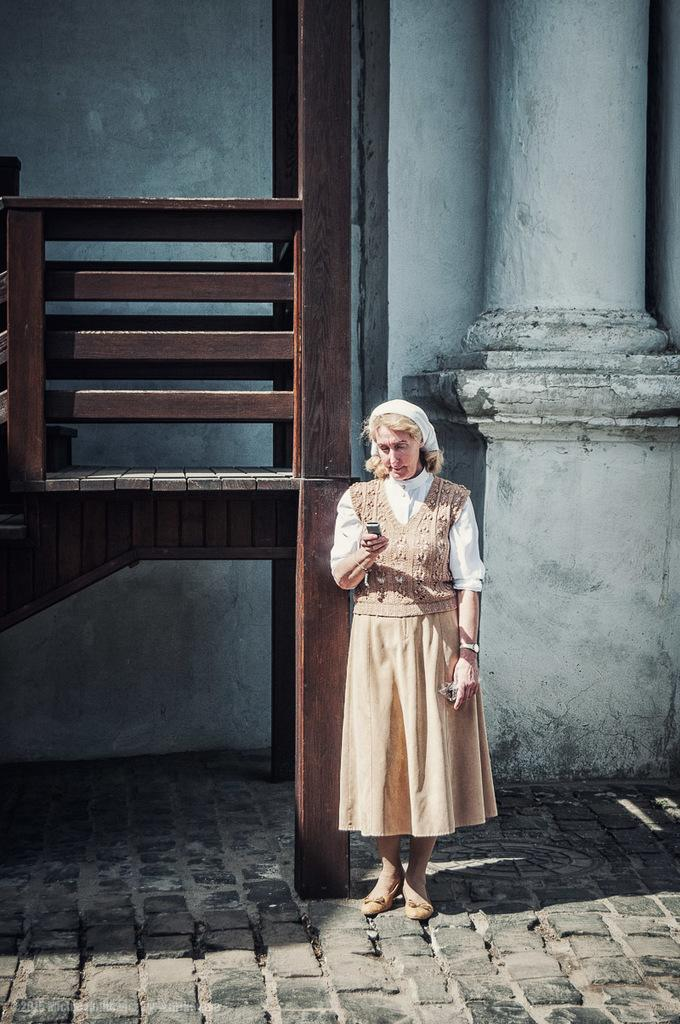What can be seen in the image? There is a person in the image. What is the person doing in the image? The person is holding an object. What type of surface is visible in the image? There is the ground visible in the image. What material is the wooden object made of? The wooden object in the image is made of wood. What can be seen in the background of the image? There is a wall and a pillar in the background of the image. Can you see the coast in the image? There is no coast visible in the image. What type of bottle is the person holding in the image? The person is not holding a bottle in the image; they are holding an object, but it is not specified as a bottle. 